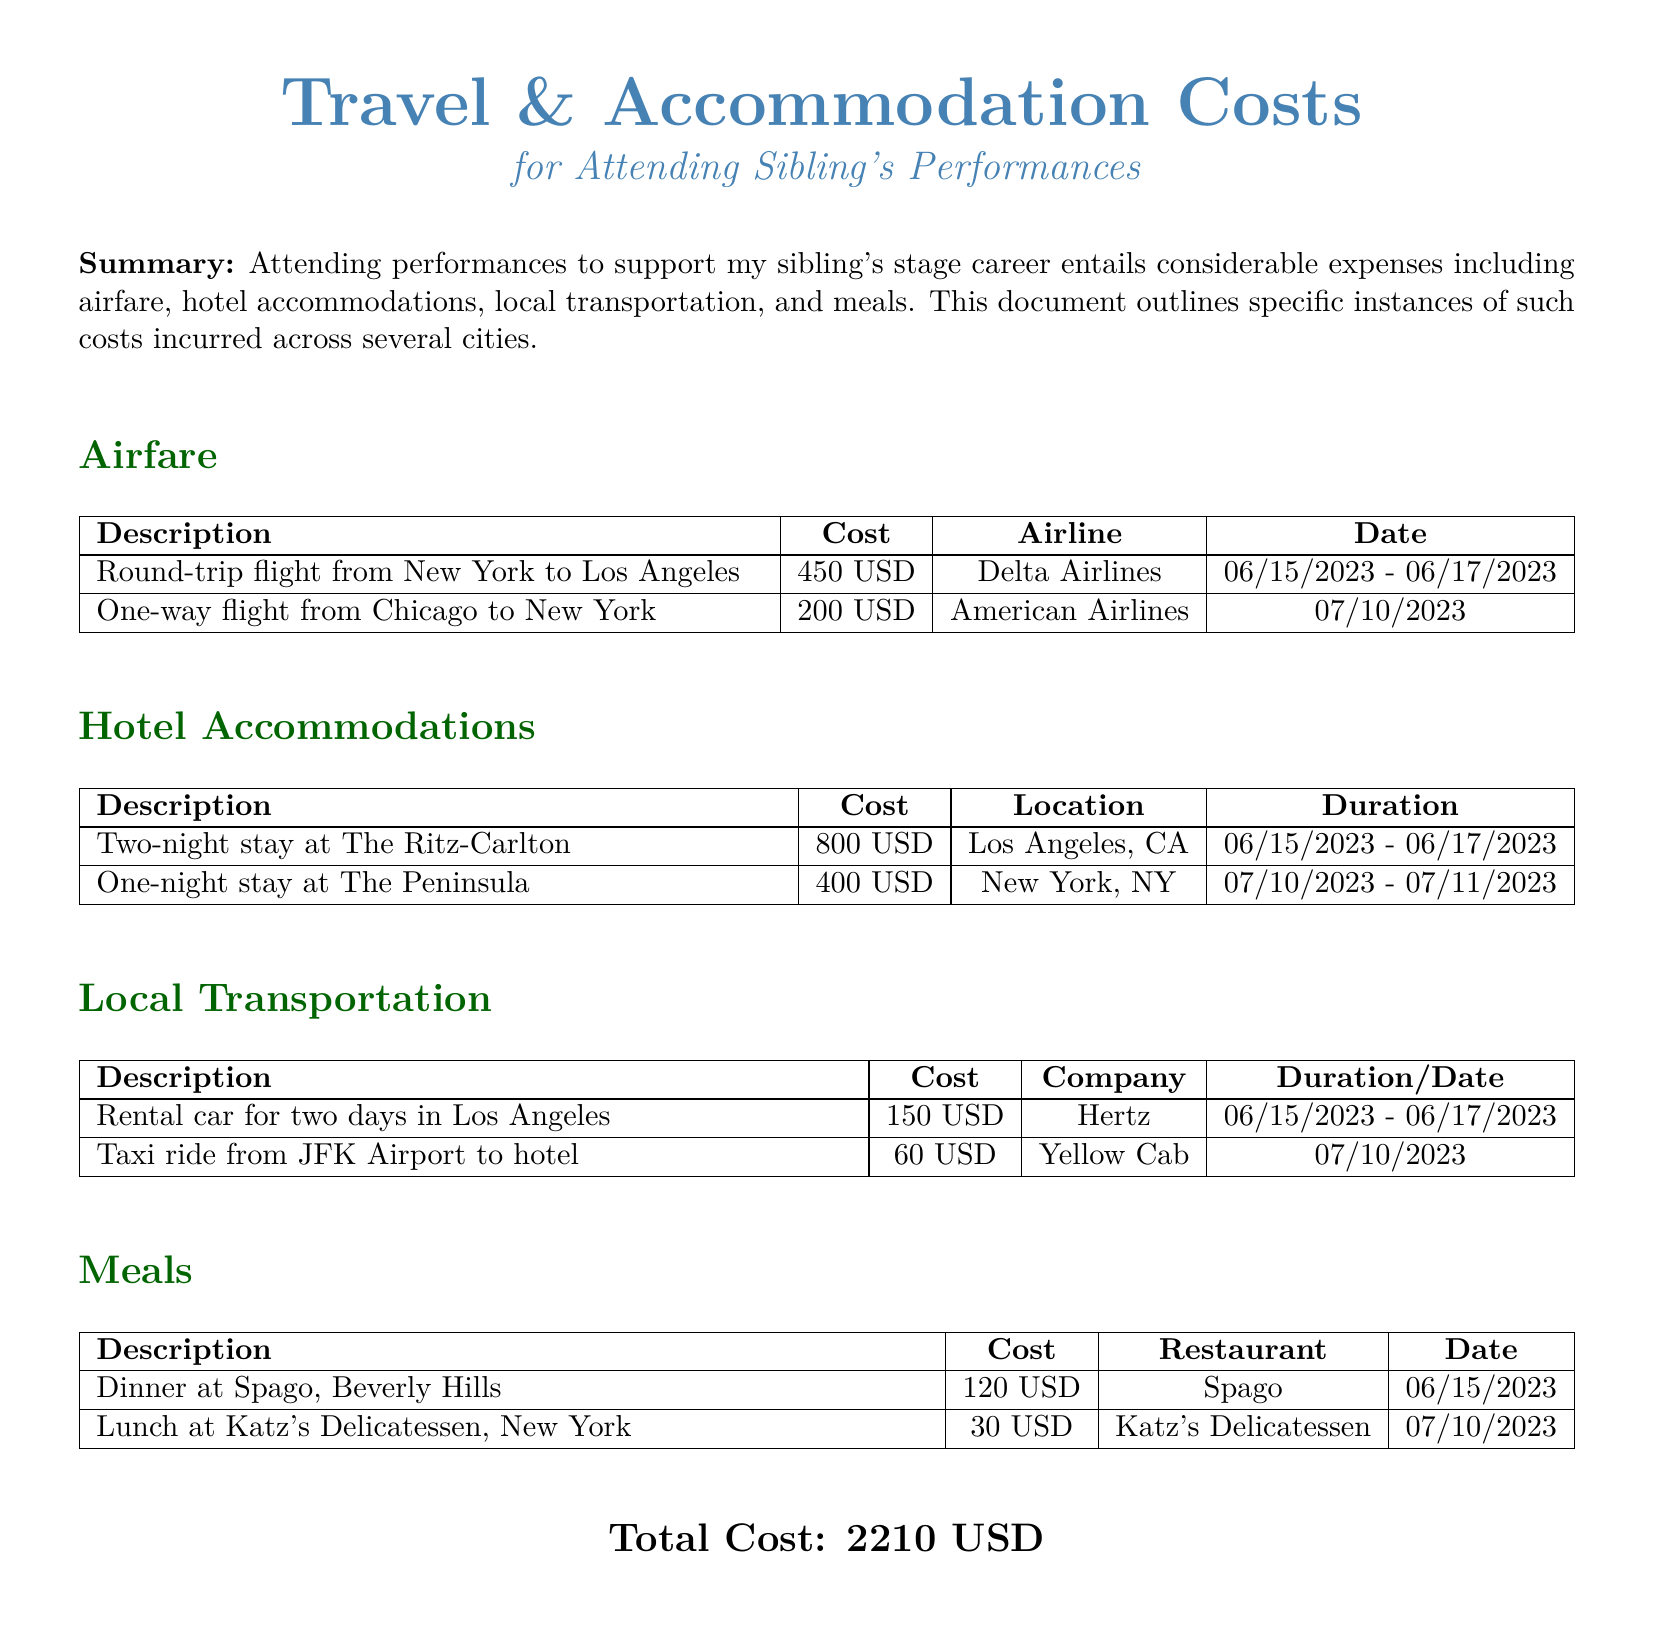What is the total cost? The total cost is listed at the bottom of the document, summing up all expenses incurred.
Answer: 2210 USD How much was the airfare to Los Angeles? The airfare section specifies the round-trip flight cost from New York to Los Angeles.
Answer: 450 USD Where did the hotel stay in New York occur? The hotel accommodations section lists the location of the hotel in New York.
Answer: New York, NY What is the name of the rental car company used in Los Angeles? The local transportation table identifies the company for the rental car expense.
Answer: Hertz How many nights did the hotel stay in Los Angeles cover? The hotel accommodations section indicates the duration of the stay in Los Angeles.
Answer: Two nights What was the cost of the dinner at Spago? The meals section provides the specific cost for dining at Spago in Beverly Hills.
Answer: 120 USD What type of transportation was used from JFK Airport to the hotel? The local transportation section specifies the type of service used for this ride.
Answer: Taxi When did the one-way flight from Chicago take place? The airfare section lists the date for the one-way flight from Chicago.
Answer: 07/10/2023 Which airline operated the round-trip flight from New York to Los Angeles? The airfare table mentions the airline for the round-trip flight in the document.
Answer: Delta Airlines 